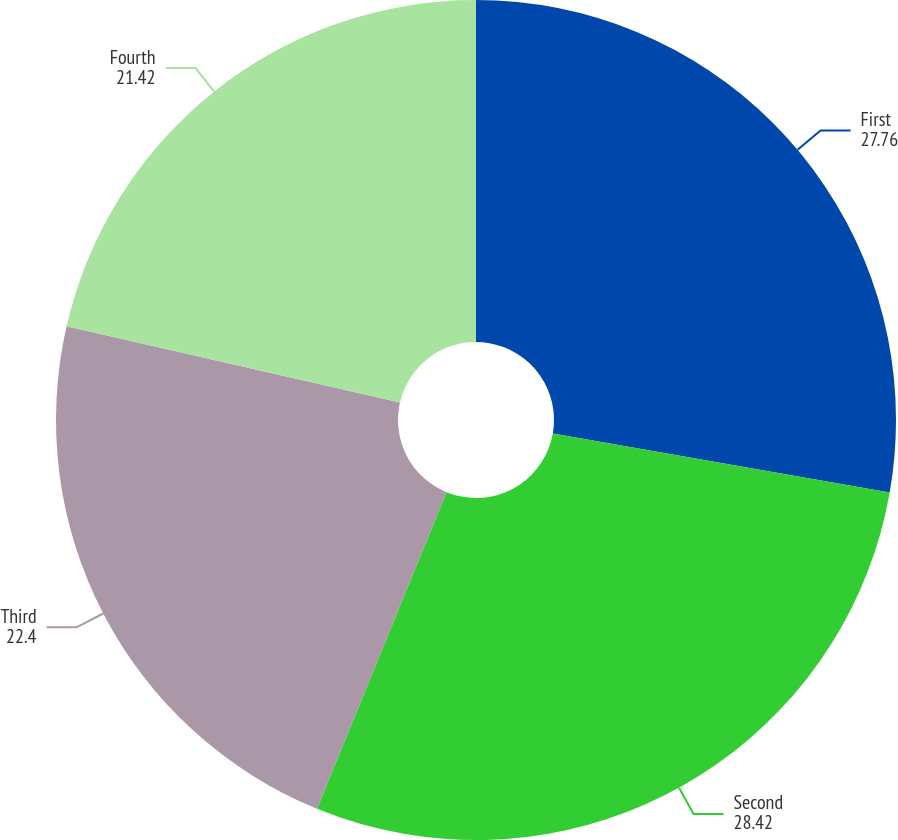Convert chart to OTSL. <chart><loc_0><loc_0><loc_500><loc_500><pie_chart><fcel>First<fcel>Second<fcel>Third<fcel>Fourth<nl><fcel>27.76%<fcel>28.42%<fcel>22.4%<fcel>21.42%<nl></chart> 